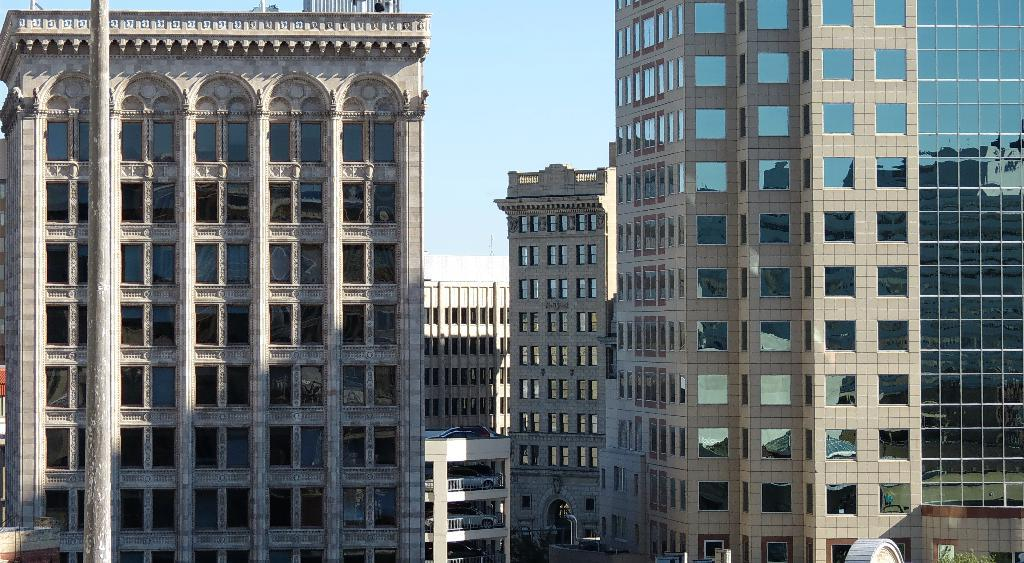What type of buildings can be seen in the image? There are glass buildings in the image. What is the condition of the sky in the image? The sky is clear and blue in the image. What color is the gold coast in the image? There is no gold coast present in the image. The image features glass buildings and a clear blue sky. 